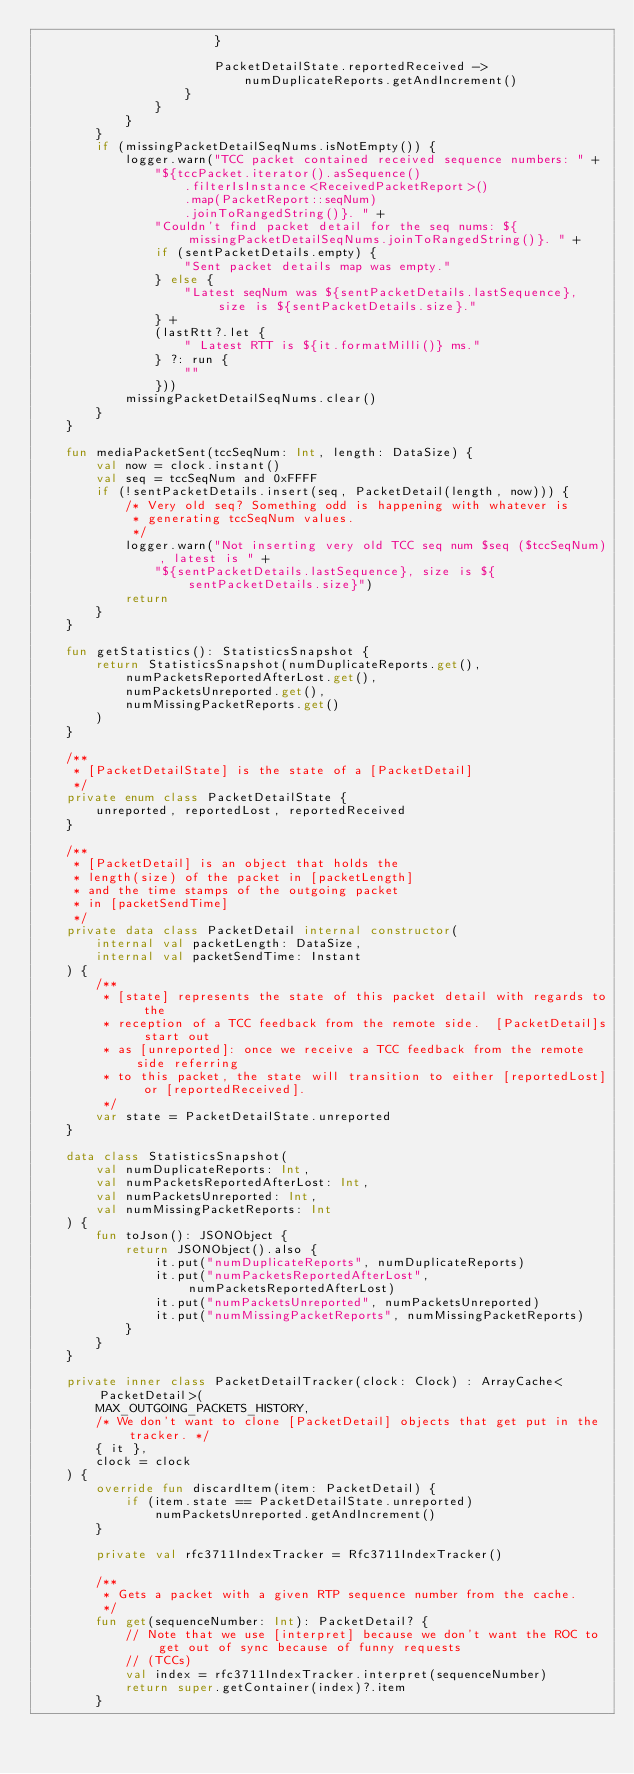<code> <loc_0><loc_0><loc_500><loc_500><_Kotlin_>                        }

                        PacketDetailState.reportedReceived ->
                            numDuplicateReports.getAndIncrement()
                    }
                }
            }
        }
        if (missingPacketDetailSeqNums.isNotEmpty()) {
            logger.warn("TCC packet contained received sequence numbers: " +
                "${tccPacket.iterator().asSequence()
                    .filterIsInstance<ReceivedPacketReport>()
                    .map(PacketReport::seqNum)
                    .joinToRangedString()}. " +
                "Couldn't find packet detail for the seq nums: ${missingPacketDetailSeqNums.joinToRangedString()}. " +
                if (sentPacketDetails.empty) {
                    "Sent packet details map was empty."
                } else {
                    "Latest seqNum was ${sentPacketDetails.lastSequence}, size is ${sentPacketDetails.size}."
                } +
                (lastRtt?.let {
                    " Latest RTT is ${it.formatMilli()} ms."
                } ?: run {
                    ""
                }))
            missingPacketDetailSeqNums.clear()
        }
    }

    fun mediaPacketSent(tccSeqNum: Int, length: DataSize) {
        val now = clock.instant()
        val seq = tccSeqNum and 0xFFFF
        if (!sentPacketDetails.insert(seq, PacketDetail(length, now))) {
            /* Very old seq? Something odd is happening with whatever is
             * generating tccSeqNum values.
             */
            logger.warn("Not inserting very old TCC seq num $seq ($tccSeqNum), latest is " +
                "${sentPacketDetails.lastSequence}, size is ${sentPacketDetails.size}")
            return
        }
    }

    fun getStatistics(): StatisticsSnapshot {
        return StatisticsSnapshot(numDuplicateReports.get(),
            numPacketsReportedAfterLost.get(),
            numPacketsUnreported.get(),
            numMissingPacketReports.get()
        )
    }

    /**
     * [PacketDetailState] is the state of a [PacketDetail]
     */
    private enum class PacketDetailState {
        unreported, reportedLost, reportedReceived
    }

    /**
     * [PacketDetail] is an object that holds the
     * length(size) of the packet in [packetLength]
     * and the time stamps of the outgoing packet
     * in [packetSendTime]
     */
    private data class PacketDetail internal constructor(
        internal val packetLength: DataSize,
        internal val packetSendTime: Instant
    ) {
        /**
         * [state] represents the state of this packet detail with regards to the
         * reception of a TCC feedback from the remote side.  [PacketDetail]s start out
         * as [unreported]: once we receive a TCC feedback from the remote side referring
         * to this packet, the state will transition to either [reportedLost] or [reportedReceived].
         */
        var state = PacketDetailState.unreported
    }

    data class StatisticsSnapshot(
        val numDuplicateReports: Int,
        val numPacketsReportedAfterLost: Int,
        val numPacketsUnreported: Int,
        val numMissingPacketReports: Int
    ) {
        fun toJson(): JSONObject {
            return JSONObject().also {
                it.put("numDuplicateReports", numDuplicateReports)
                it.put("numPacketsReportedAfterLost", numPacketsReportedAfterLost)
                it.put("numPacketsUnreported", numPacketsUnreported)
                it.put("numMissingPacketReports", numMissingPacketReports)
            }
        }
    }

    private inner class PacketDetailTracker(clock: Clock) : ArrayCache<PacketDetail>(
        MAX_OUTGOING_PACKETS_HISTORY,
        /* We don't want to clone [PacketDetail] objects that get put in the tracker. */
        { it },
        clock = clock
    ) {
        override fun discardItem(item: PacketDetail) {
            if (item.state == PacketDetailState.unreported)
                numPacketsUnreported.getAndIncrement()
        }

        private val rfc3711IndexTracker = Rfc3711IndexTracker()

        /**
         * Gets a packet with a given RTP sequence number from the cache.
         */
        fun get(sequenceNumber: Int): PacketDetail? {
            // Note that we use [interpret] because we don't want the ROC to get out of sync because of funny requests
            // (TCCs)
            val index = rfc3711IndexTracker.interpret(sequenceNumber)
            return super.getContainer(index)?.item
        }
</code> 